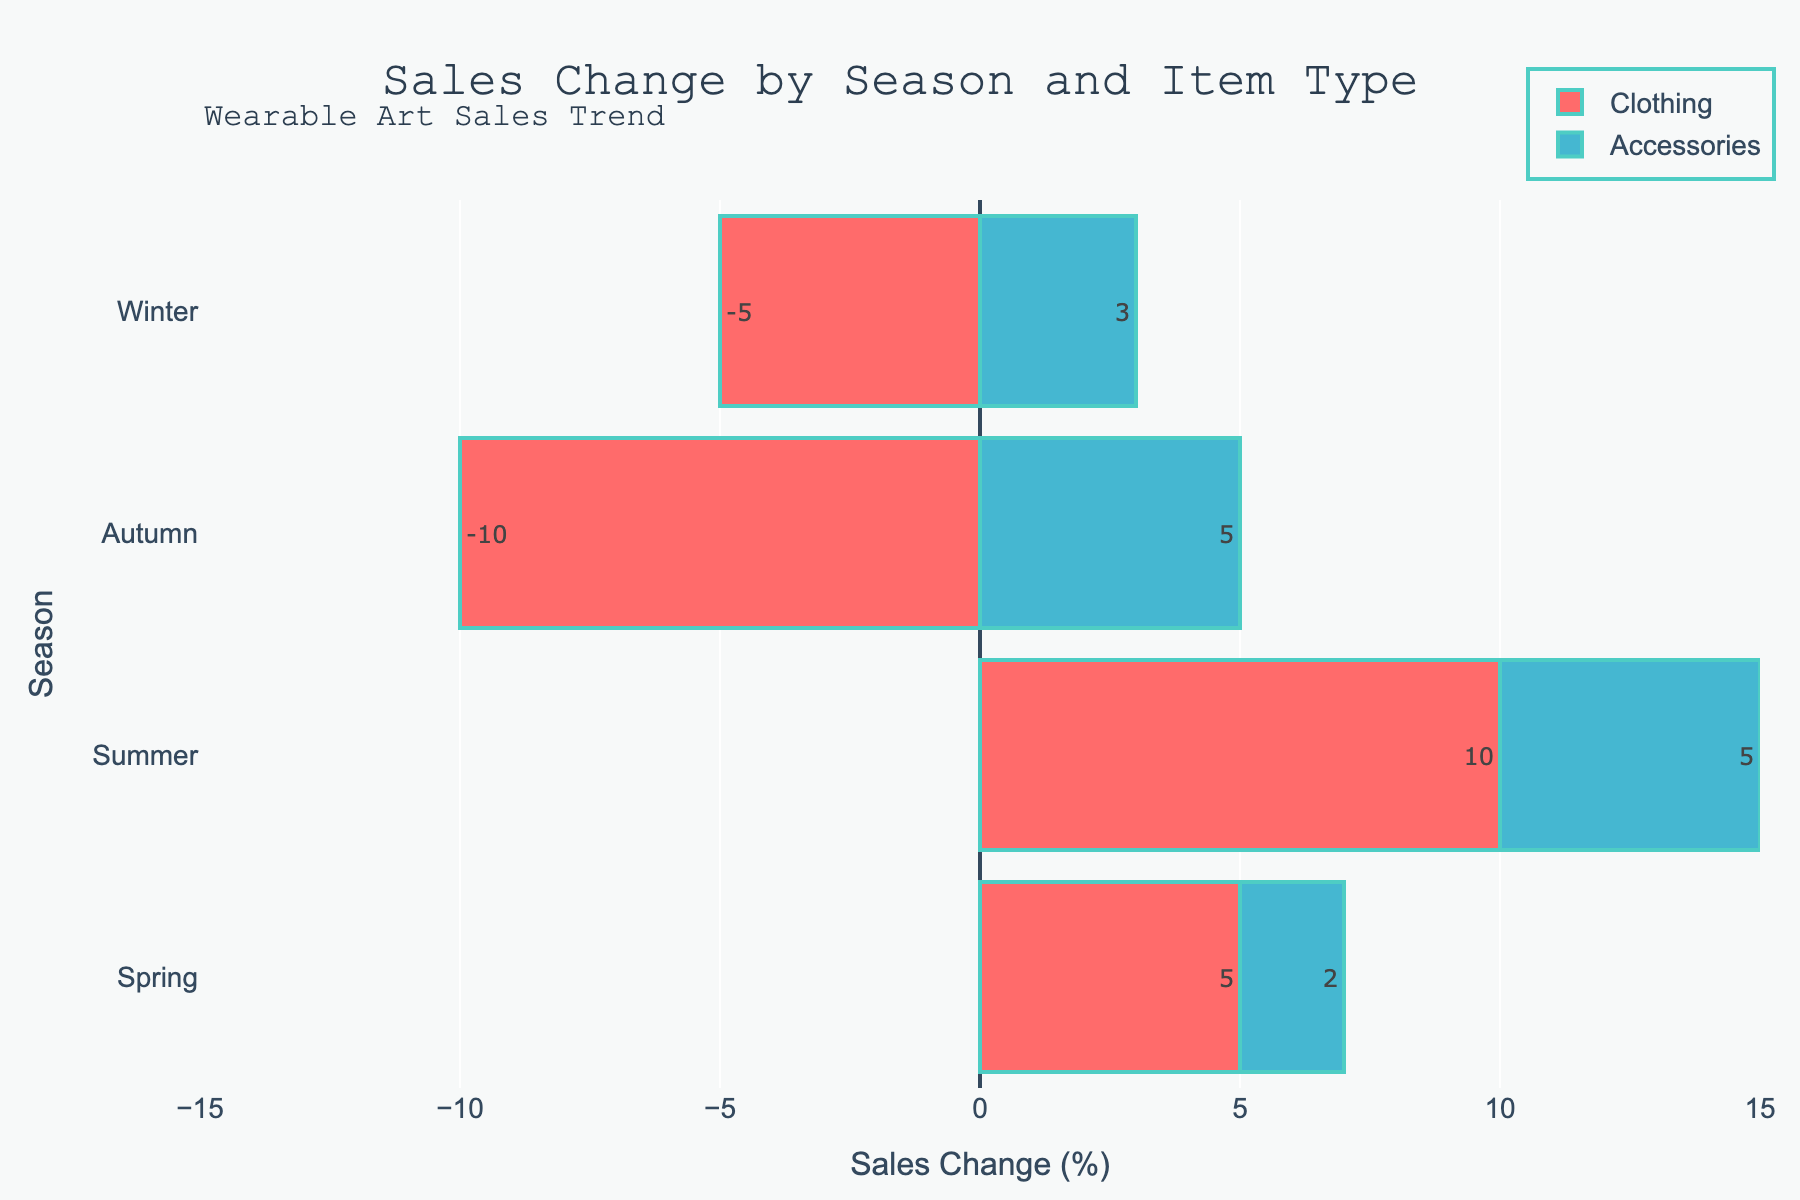Which season had the highest sales change for clothing? In the graph, the bar lengths for "Clothing" across the seasons can be compared. The longest bar for "Clothing" is in the summer season, indicating the highest sales change.
Answer: Summer Which item type had a positive sales change in all four seasons? By checking both bars for each season, "Accessories" shows a positive sales change in all four seasons, whereas "Clothing" does not.
Answer: Accessories What is the total sales change for accessories across all seasons? To find the total sales change for accessories, add the sales changes: 2 (Spring) + 5 (Summer) + 5 (Autumn) + 3 (Winter). This sums up to 15.
Answer: 15 How does the sales change for clothing in winter compare to that in autumn? Compare the bar lengths for "Clothing" in autumn and winter. In winter, it is -5 and in autumn it is -10. Therefore, the winter sales change is 5 higher than the autumn sales change since -5 > -10.
Answer: Winter is higher Which season had the smallest sales change for accessories? The smallest bar for "Accessories" is in the Spring season, indicating the smallest sales change for that season.
Answer: Spring What is the difference in total sales change between clothing and accessories across all seasons? Find total sales change for clothing and accessories: Clothing: 5 (Spring) + 10 (Summer) + (-10) (Autumn) + (-5) (Winter) = 0; Accessories: 2 (Spring) + 5 (Summer) + 5 (Autumn) + 3 (Winter) = 15. The difference is 15 - 0 = 15.
Answer: 15 Which season shows the most balanced sales change between clothing and accessories? The most balanced season has bars of almost equal length for both item types. Autumn has bars of equal length for both (25 and 25).
Answer: Autumn How does the sales change in spring compare to winter for clothing? The bars for "Clothing" in spring and winter are compared. In spring, the sales change is 5, whereas in winter it is -5, thus the difference is 10.
Answer: Spring is higher by 10 